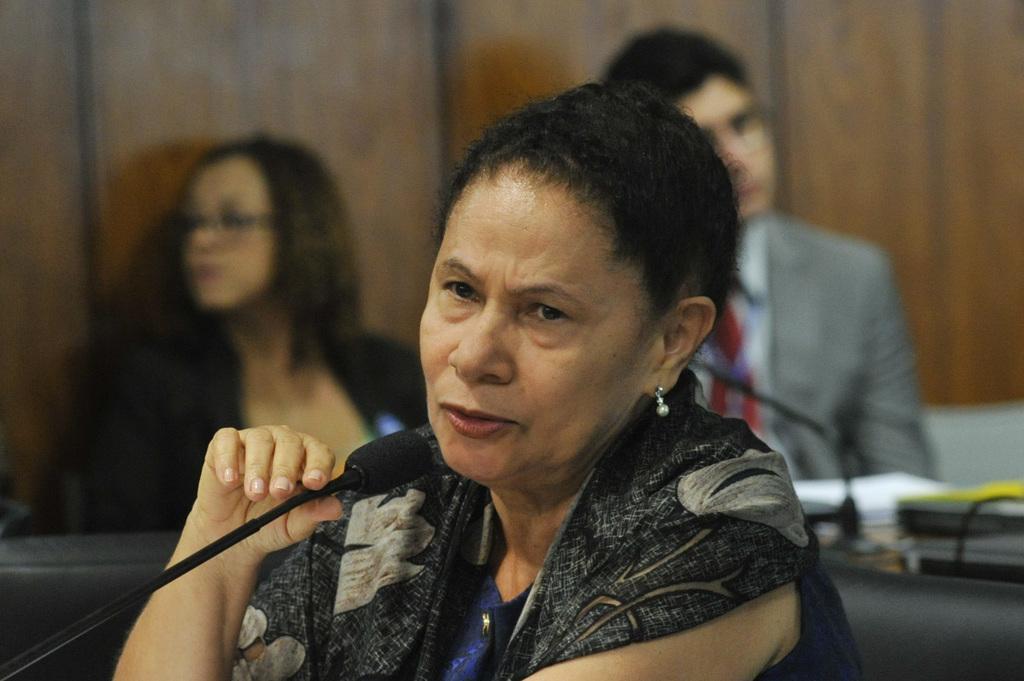Please provide a concise description of this image. There is a woman in violet color t-shirt, wearing a scarf, sitting on the chair, holding a mic and speaking. In the background, there is a man and woman sitting on a chair, near a wooden wall and in front of a table, on which, there is a mic and books. 